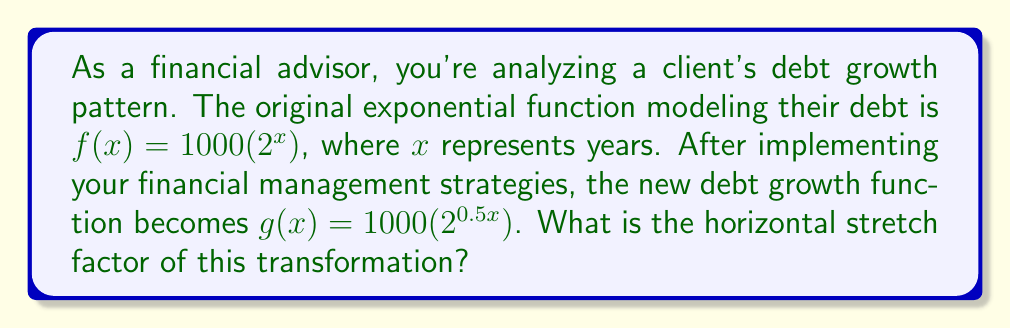Help me with this question. To find the horizontal stretch factor, we need to compare the original function $f(x)$ with the transformed function $g(x)$.

1) The general form of an exponential function is:
   $f(x) = a(b^x)$

2) Our original function is:
   $f(x) = 1000(2^x)$

3) The transformed function is:
   $g(x) = 1000(2^{0.5x})$

4) To find the horizontal stretch factor, we need to express $g(x)$ in terms of $f(x)$:
   $g(x) = 1000(2^{0.5x}) = f(0.5x)$

5) The general form of a horizontal stretch is:
   $g(x) = f(kx)$, where $k$ is the stretch factor

6) Comparing our transformation to the general form:
   $g(x) = f(0.5x)$

7) Therefore, $k = 0.5$

8) The horizontal stretch factor is the reciprocal of $k$:
   Horizontal stretch factor = $\frac{1}{k} = \frac{1}{0.5} = 2$

This means the graph of $g(x)$ is stretched horizontally by a factor of 2 compared to $f(x)$, which indicates that the debt is growing at half the original rate.
Answer: The horizontal stretch factor is 2. 